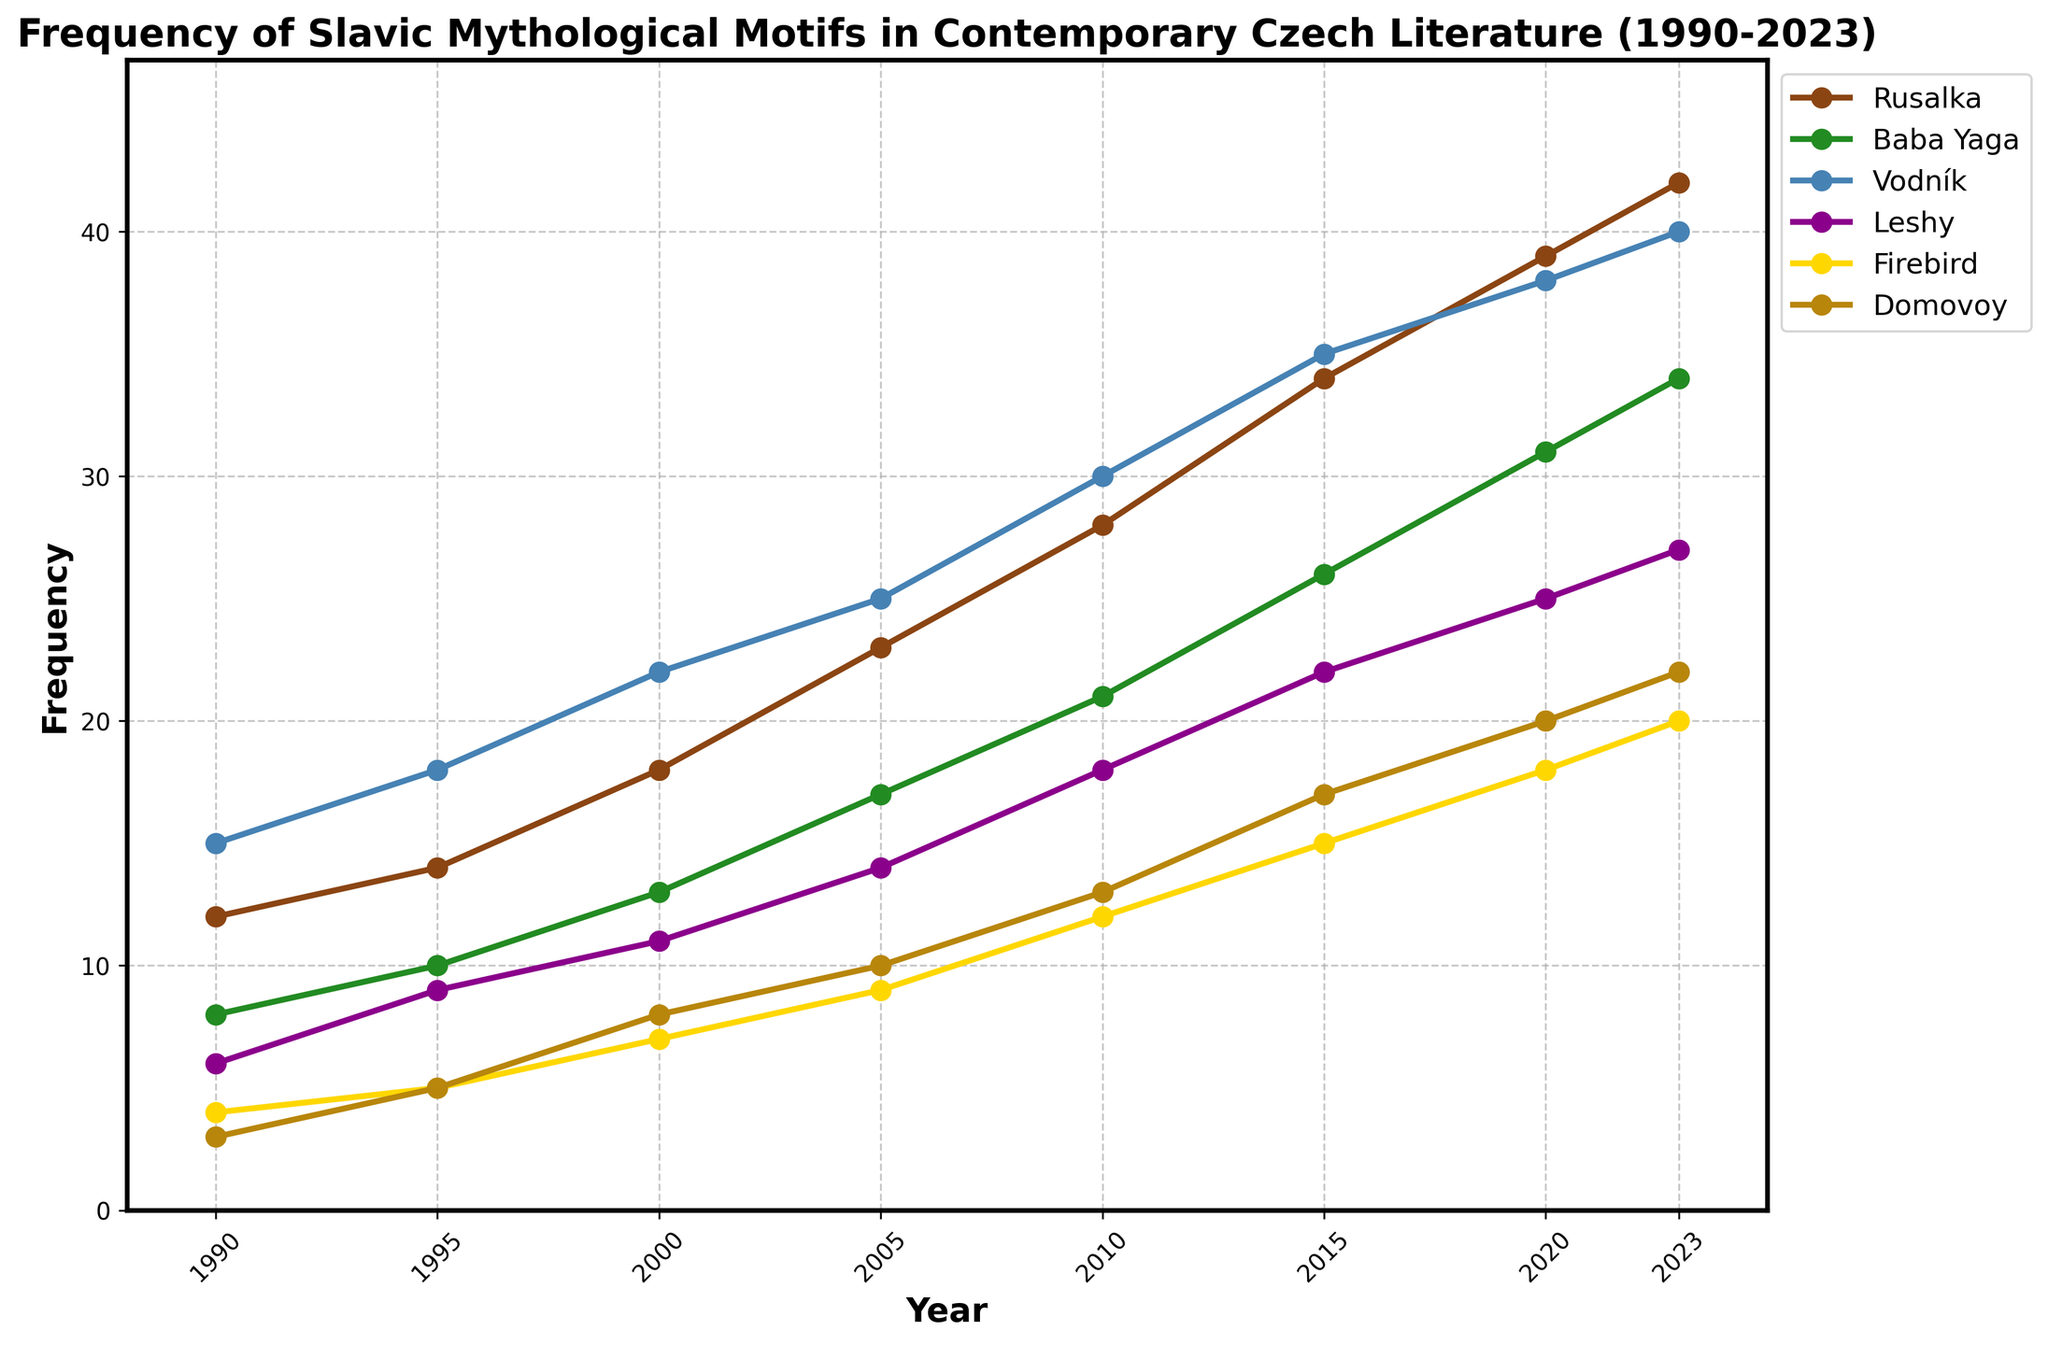How has the frequency of the motif 'Rusalka' changed from 1990 to 2023? The frequency of 'Rusalka' starts at 12 in 1990 and increases to 42 in 2023. Calculation: 42 (2023) - 12 (1990) = 30
Answer: Increased by 30 In which year did the motif 'Leshy' see the highest frequency? The highest frequency of 'Leshy' can be seen in the year 2023 where the value reaches 27
Answer: 2023 Compare the frequency of 'Baba Yaga' and 'Firebird' in 2015. Which motif had a higher occurrence? In 2015, 'Baba Yaga' has a frequency of 26 while 'Firebird' has a frequency of 15. Since 26 > 15, 'Baba Yaga' had a higher occurrence
Answer: Baba Yaga Which motif has the smallest increase in frequency from 1990 to 2023? The frequency of each motif in 2023 subtracted from the frequency in 1990 shows that: Rusalka: 42-12 = 30, Baba Yaga: 34-8 = 26, Vodník: 40-15 = 25, Leshy: 27-6 = 21, Firebird: 20-4 = 16, Domovoy: 22-3 = 19. 'Firebird' has the smallest increase of 16.
Answer: Firebird What is the average frequency of 'Domovoy' over the entire period? Add all the frequencies of 'Domovoy' from 1990 to 2023 and divide by the number of years. (3+5+8+10+13+17+20+22)/8 = 12.25
Answer: 12.25 Which motif has the highest frequency in 2000, and what is the value? In the year 2000, 'Vodník' has the highest frequency with a value of 22 as compared to the other motifs: Rusalka (18), Baba Yaga (13), Leshy (11), Firebird (7), and Domovoy (8).
Answer: Vodník, 22 What is the total frequency of all motifs combined in the year 2010? The combined frequency of all motifs in 2010: 28 (Rusalka) + 21 (Baba Yaga) + 30 (Vodník) + 18 (Leshy) + 12 (Firebird) + 13 (Domovoy) = 122.
Answer: 122 Determine the rate of increase per year for 'Vodník' from 1990 to 2023. The frequency of 'Vodník' increases from 15 in 1990 to 40 in 2023. Rate of increase per year: (40 - 15) / (2023 - 1990) = 25 / 33 ≈ 0.76.
Answer: 0.76 Visually, which motif appears to have the steepest line in the plot from 1990 to 2023? Observing the steepness of the lines in the plot, 'Rusalka' appears to have the steepest line because it shows the largest increase in frequency from 12 to 42.
Answer: Rusalka How does the frequency of 'Leshy' in 2023 compare to its frequency in 2005? The frequency of 'Leshy' in 2023 is 27, while in 2005 it is 14. Calculation: 27 - 14 = 13. The frequency of 'Leshy' in 2023 is higher by 13.
Answer: 13 